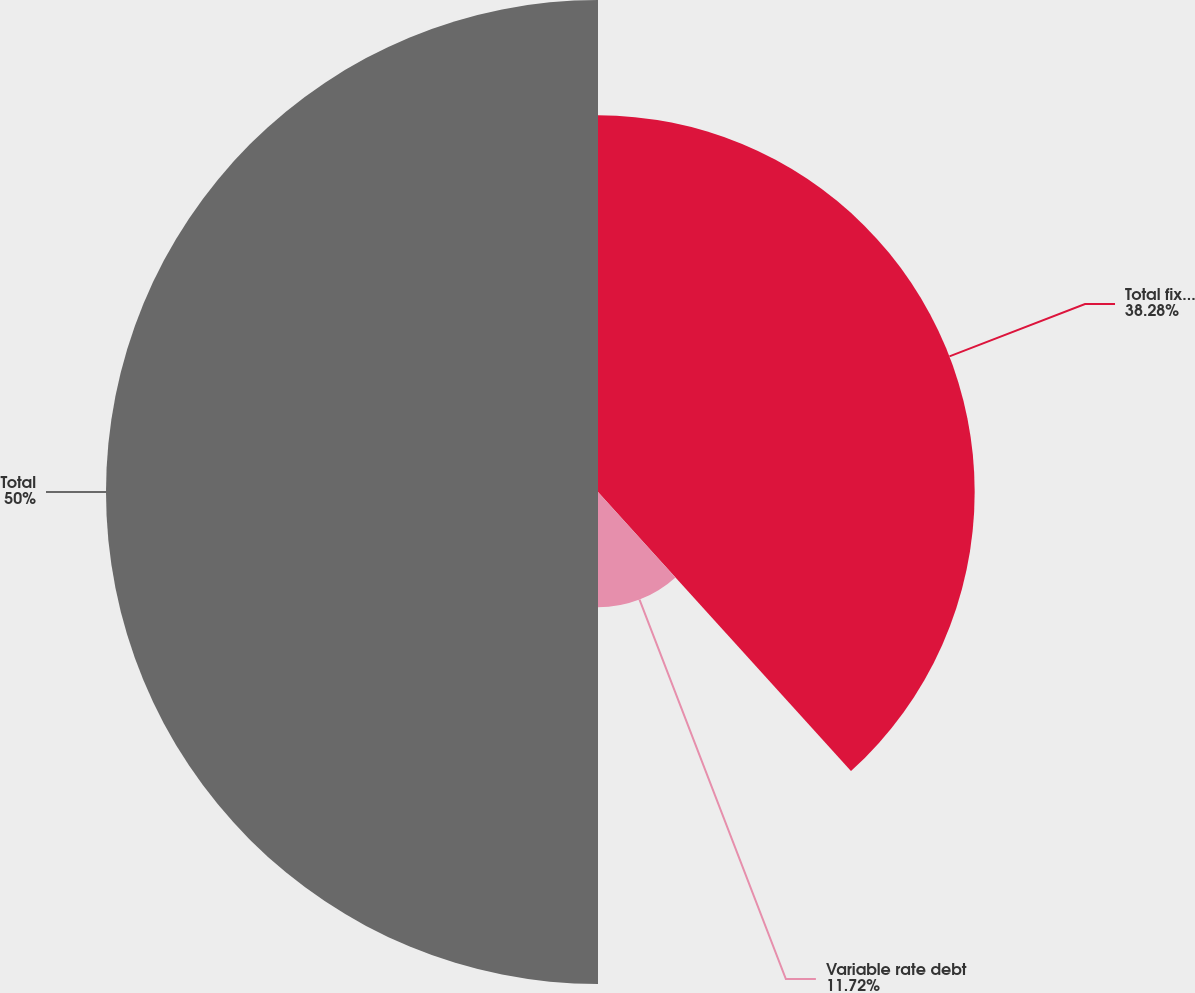Convert chart to OTSL. <chart><loc_0><loc_0><loc_500><loc_500><pie_chart><fcel>Total fixed rate debt<fcel>Variable rate debt<fcel>Total<nl><fcel>38.28%<fcel>11.72%<fcel>50.0%<nl></chart> 